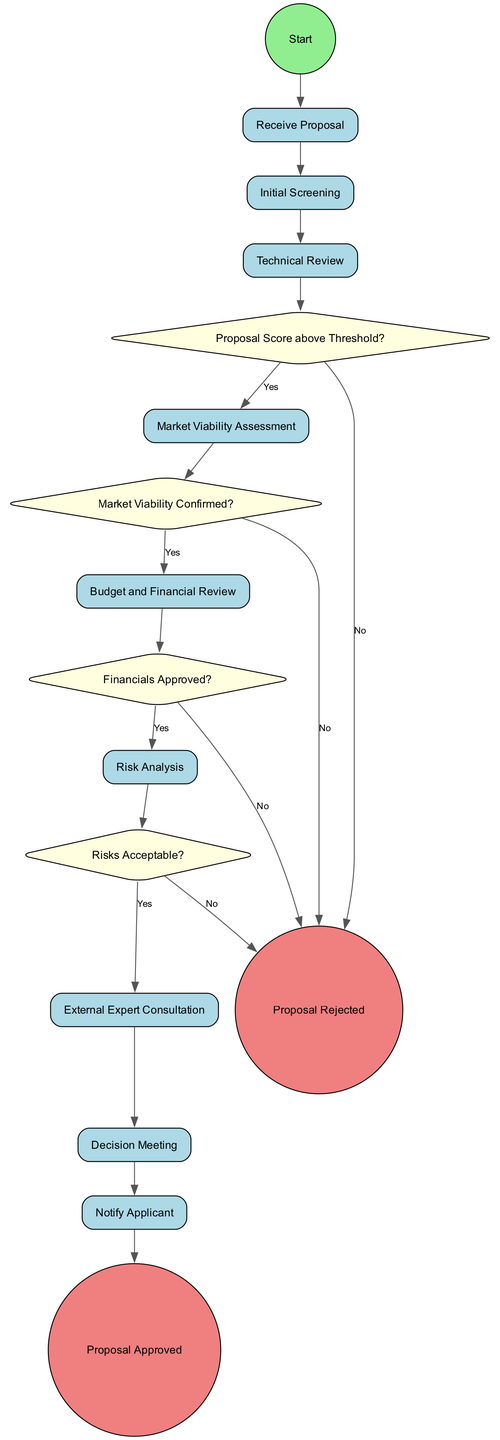what is the first activity in the diagram? The diagram begins with the "Receive Proposal" activity, which is represented as the first action in the flowchart following the start event.
Answer: Receive Proposal how many decision points are in the diagram? There are four decision points indicated in the diagram, each represented as a diamond shape. The points evaluate the proposal at different stages in the review process.
Answer: 4 what happens after the "Technical Review" activity? Following the "Technical Review," the process moves to the decision point "Proposal Score above Threshold?" which determines the next step based on the outcome of the review.
Answer: Proposal Score above Threshold? if the "Market Viability Assessment" is confirmed, what is the next activity? If the "Market Viability Assessment" is confirmed, the flow continues to the "Budget and Financial Review" activity, as indicated by a 'Yes' edge leading to that activity.
Answer: Budget and Financial Review what is the outcome if risks are not acceptable? If the identified risks are deemed unacceptable, the flow leads to the "Proposal Rejected" end event, indicating that the proposal cannot proceed.
Answer: Proposal Rejected which activity follows the "Decision Meeting"? The activity that follows the "Decision Meeting" is "Notify Applicant," where the applicant is informed about the decision made by the approval committee.
Answer: Notify Applicant how does one move from "Initial Screening" to "Technical Review"? After completing "Initial Screening," the process directly proceeds to "Technical Review" as indicated by a connecting edge with no decision point in between.
Answer: Directly to Technical Review what decision is evaluated after the "Budget and Financial Review"? After the "Budget and Financial Review," the decision evaluated is whether the financial projections are approved, indicated by the decision point "Financials Approved?"
Answer: Financials Approved? 